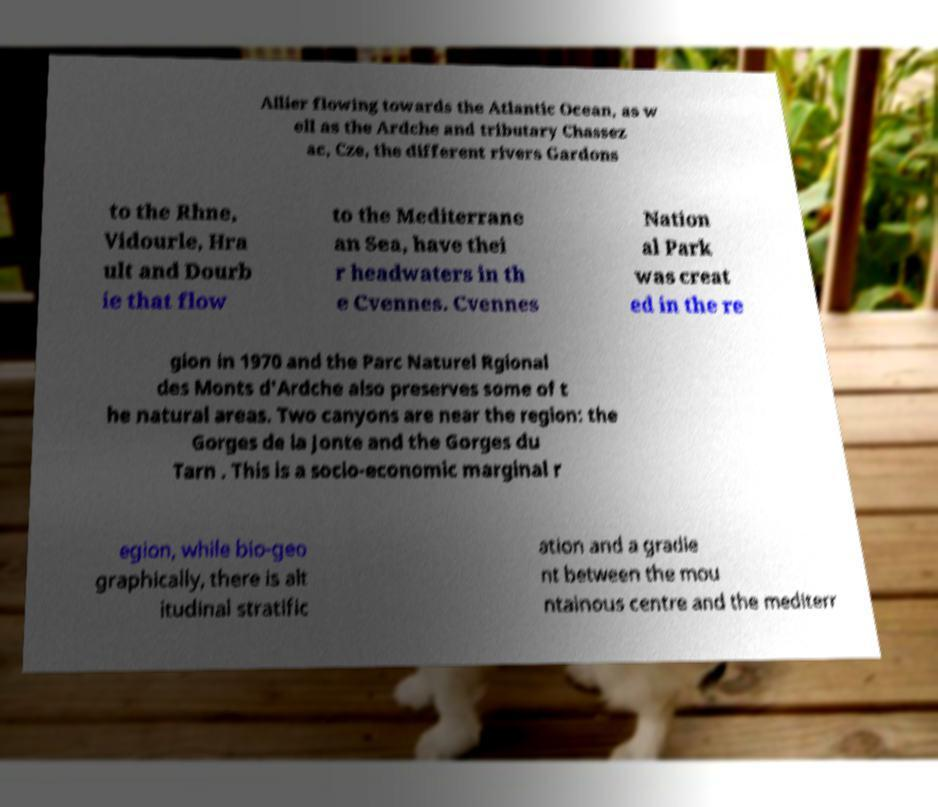There's text embedded in this image that I need extracted. Can you transcribe it verbatim? Allier flowing towards the Atlantic Ocean, as w ell as the Ardche and tributary Chassez ac, Cze, the different rivers Gardons to the Rhne, Vidourle, Hra ult and Dourb ie that flow to the Mediterrane an Sea, have thei r headwaters in th e Cvennes. Cvennes Nation al Park was creat ed in the re gion in 1970 and the Parc Naturel Rgional des Monts d'Ardche also preserves some of t he natural areas. Two canyons are near the region: the Gorges de la Jonte and the Gorges du Tarn . This is a socio-economic marginal r egion, while bio-geo graphically, there is alt itudinal stratific ation and a gradie nt between the mou ntainous centre and the mediterr 